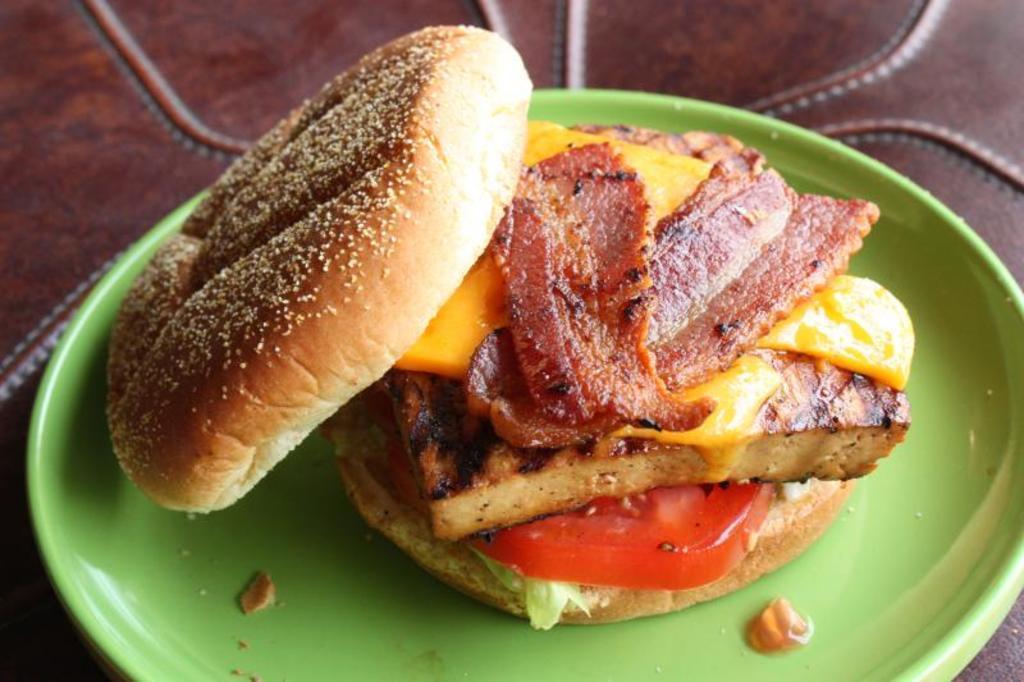How would you summarize this image in a sentence or two? In this picture we can see a plate with a food on it and this plate is placed on an object. 